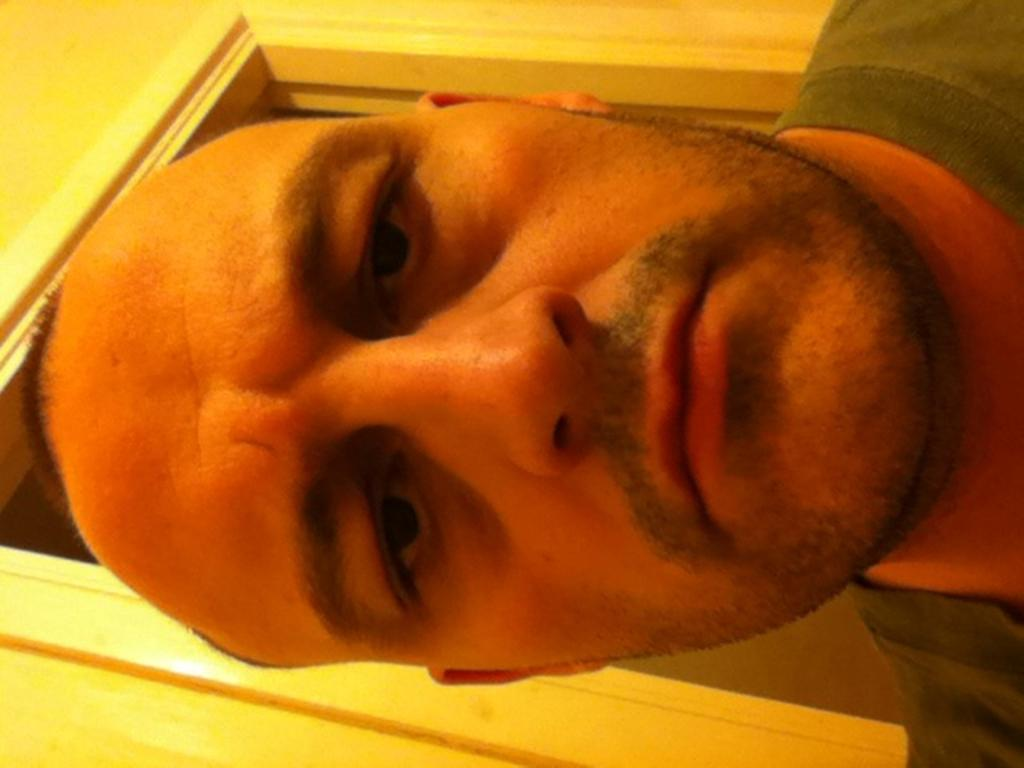What is the main subject of the image? There is a man in the image. What can be seen in the background of the image? There is a wall and a door visible in the background of the image. What type of fight is taking place between the man and the bear in the image? There is no bear present in the image, and therefore no fight cannot be observed. What part of the man's flesh is visible in the image? There is no flesh visible in the image, as it is a picture of a man and a wall with a door. 